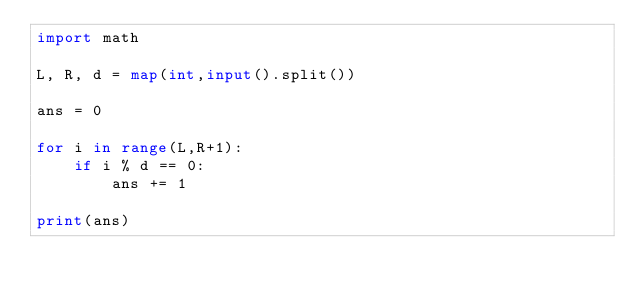<code> <loc_0><loc_0><loc_500><loc_500><_Python_>import math

L, R, d = map(int,input().split())

ans = 0

for i in range(L,R+1):
    if i % d == 0:
        ans += 1

print(ans)</code> 